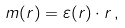Convert formula to latex. <formula><loc_0><loc_0><loc_500><loc_500>m ( r ) = \varepsilon ( r ) \cdot r \, ,</formula> 